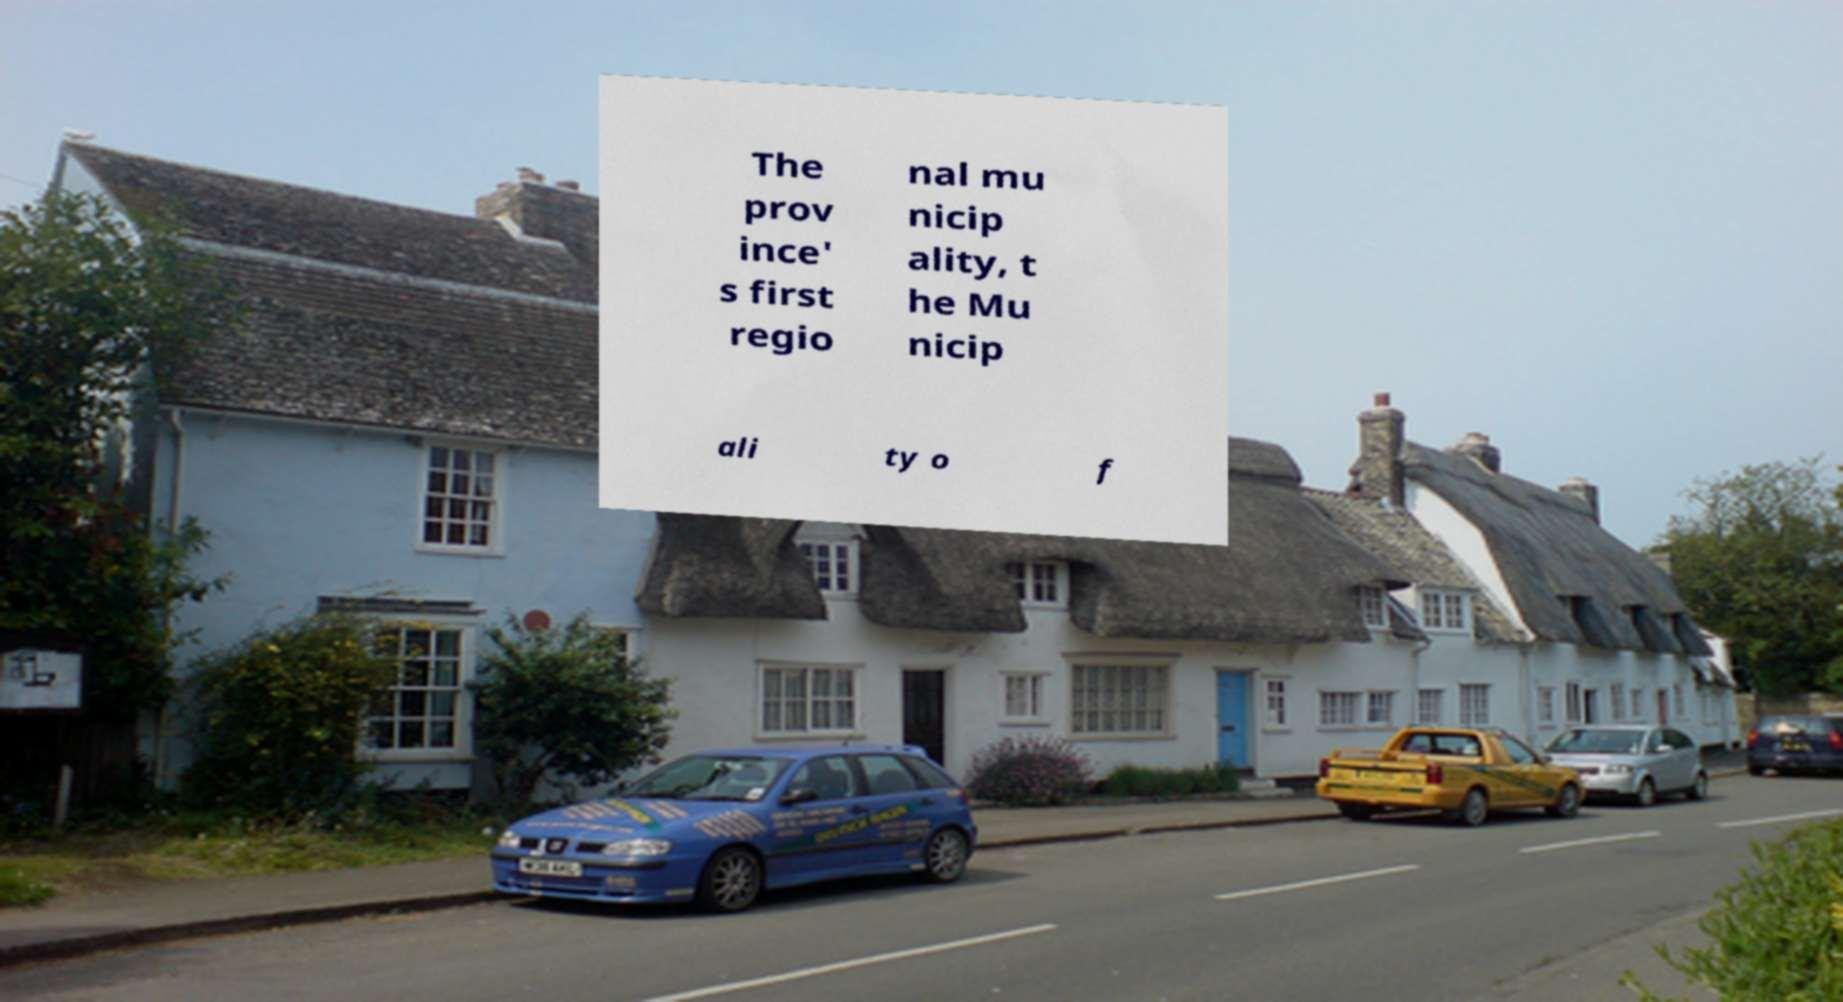Please identify and transcribe the text found in this image. The prov ince' s first regio nal mu nicip ality, t he Mu nicip ali ty o f 